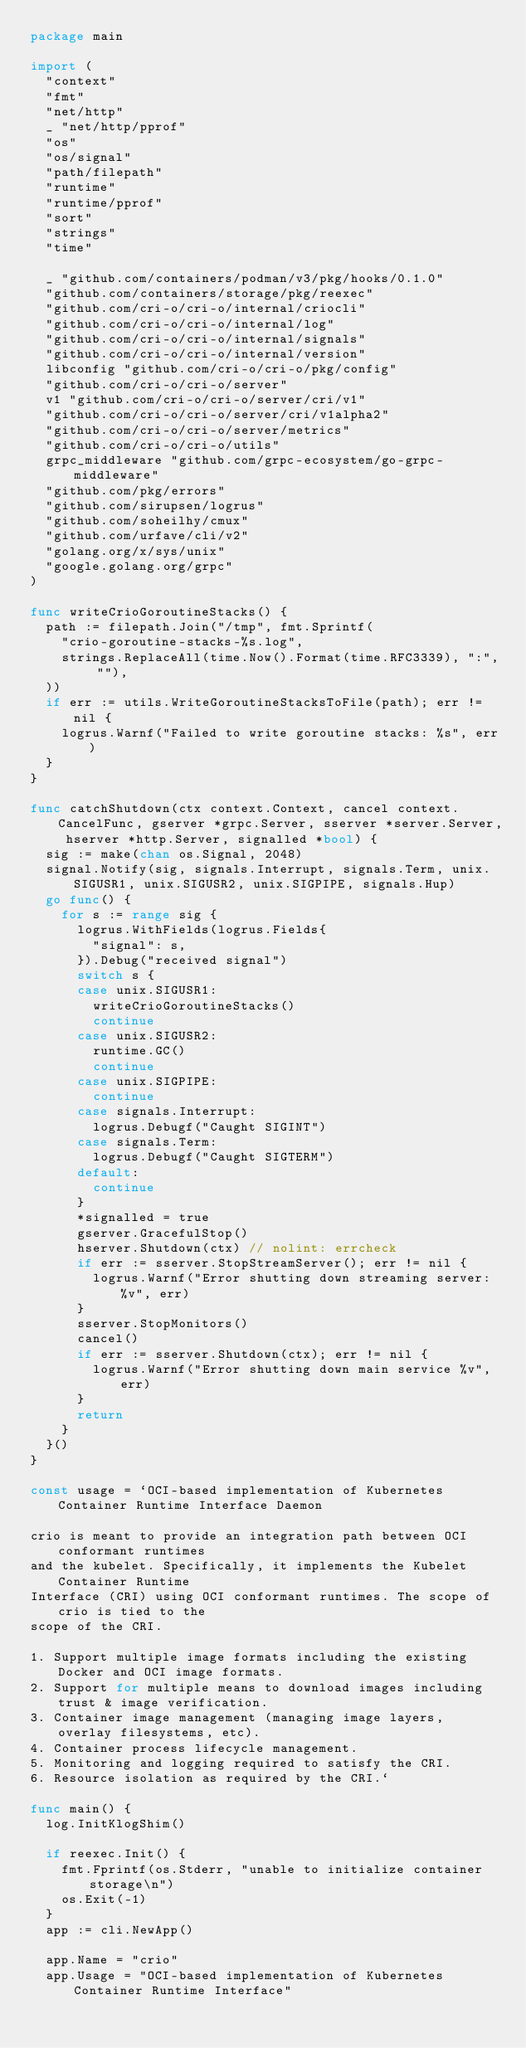<code> <loc_0><loc_0><loc_500><loc_500><_Go_>package main

import (
	"context"
	"fmt"
	"net/http"
	_ "net/http/pprof"
	"os"
	"os/signal"
	"path/filepath"
	"runtime"
	"runtime/pprof"
	"sort"
	"strings"
	"time"

	_ "github.com/containers/podman/v3/pkg/hooks/0.1.0"
	"github.com/containers/storage/pkg/reexec"
	"github.com/cri-o/cri-o/internal/criocli"
	"github.com/cri-o/cri-o/internal/log"
	"github.com/cri-o/cri-o/internal/signals"
	"github.com/cri-o/cri-o/internal/version"
	libconfig "github.com/cri-o/cri-o/pkg/config"
	"github.com/cri-o/cri-o/server"
	v1 "github.com/cri-o/cri-o/server/cri/v1"
	"github.com/cri-o/cri-o/server/cri/v1alpha2"
	"github.com/cri-o/cri-o/server/metrics"
	"github.com/cri-o/cri-o/utils"
	grpc_middleware "github.com/grpc-ecosystem/go-grpc-middleware"
	"github.com/pkg/errors"
	"github.com/sirupsen/logrus"
	"github.com/soheilhy/cmux"
	"github.com/urfave/cli/v2"
	"golang.org/x/sys/unix"
	"google.golang.org/grpc"
)

func writeCrioGoroutineStacks() {
	path := filepath.Join("/tmp", fmt.Sprintf(
		"crio-goroutine-stacks-%s.log",
		strings.ReplaceAll(time.Now().Format(time.RFC3339), ":", ""),
	))
	if err := utils.WriteGoroutineStacksToFile(path); err != nil {
		logrus.Warnf("Failed to write goroutine stacks: %s", err)
	}
}

func catchShutdown(ctx context.Context, cancel context.CancelFunc, gserver *grpc.Server, sserver *server.Server, hserver *http.Server, signalled *bool) {
	sig := make(chan os.Signal, 2048)
	signal.Notify(sig, signals.Interrupt, signals.Term, unix.SIGUSR1, unix.SIGUSR2, unix.SIGPIPE, signals.Hup)
	go func() {
		for s := range sig {
			logrus.WithFields(logrus.Fields{
				"signal": s,
			}).Debug("received signal")
			switch s {
			case unix.SIGUSR1:
				writeCrioGoroutineStacks()
				continue
			case unix.SIGUSR2:
				runtime.GC()
				continue
			case unix.SIGPIPE:
				continue
			case signals.Interrupt:
				logrus.Debugf("Caught SIGINT")
			case signals.Term:
				logrus.Debugf("Caught SIGTERM")
			default:
				continue
			}
			*signalled = true
			gserver.GracefulStop()
			hserver.Shutdown(ctx) // nolint: errcheck
			if err := sserver.StopStreamServer(); err != nil {
				logrus.Warnf("Error shutting down streaming server: %v", err)
			}
			sserver.StopMonitors()
			cancel()
			if err := sserver.Shutdown(ctx); err != nil {
				logrus.Warnf("Error shutting down main service %v", err)
			}
			return
		}
	}()
}

const usage = `OCI-based implementation of Kubernetes Container Runtime Interface Daemon

crio is meant to provide an integration path between OCI conformant runtimes
and the kubelet. Specifically, it implements the Kubelet Container Runtime
Interface (CRI) using OCI conformant runtimes. The scope of crio is tied to the
scope of the CRI.

1. Support multiple image formats including the existing Docker and OCI image formats.
2. Support for multiple means to download images including trust & image verification.
3. Container image management (managing image layers, overlay filesystems, etc).
4. Container process lifecycle management.
5. Monitoring and logging required to satisfy the CRI.
6. Resource isolation as required by the CRI.`

func main() {
	log.InitKlogShim()

	if reexec.Init() {
		fmt.Fprintf(os.Stderr, "unable to initialize container storage\n")
		os.Exit(-1)
	}
	app := cli.NewApp()

	app.Name = "crio"
	app.Usage = "OCI-based implementation of Kubernetes Container Runtime Interface"</code> 